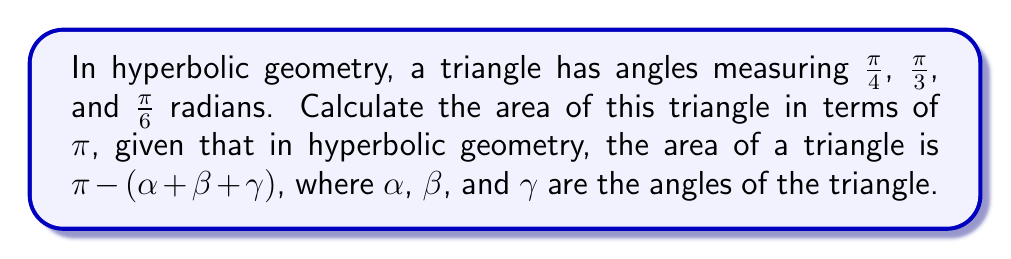What is the answer to this math problem? To solve this problem, we'll follow these steps:

1) First, let's recall the formula for the area of a hyperbolic triangle:

   $$ A = \pi - (\alpha + \beta + \gamma) $$

   where $A$ is the area, and $\alpha$, $\beta$, and $\gamma$ are the angles of the triangle.

2) We're given the following angles:
   $\alpha = \frac{\pi}{4}$
   $\beta = \frac{\pi}{3}$
   $\gamma = \frac{\pi}{6}$

3) Let's sum these angles:

   $$ \alpha + \beta + \gamma = \frac{\pi}{4} + \frac{\pi}{3} + \frac{\pi}{6} $$

4) To add these fractions, we need a common denominator. The least common multiple of 4, 3, and 6 is 12. So:

   $$ \frac{\pi}{4} + \frac{\pi}{3} + \frac{\pi}{6} = \frac{3\pi}{12} + \frac{4\pi}{12} + \frac{2\pi}{12} = \frac{9\pi}{12} = \frac{3\pi}{4} $$

5) Now we can substitute this into our area formula:

   $$ A = \pi - \frac{3\pi}{4} $$

6) Simplify:

   $$ A = \frac{4\pi}{4} - \frac{3\pi}{4} = \frac{\pi}{4} $$

Therefore, the area of the hyperbolic triangle is $\frac{\pi}{4}$.
Answer: $\frac{\pi}{4}$ 